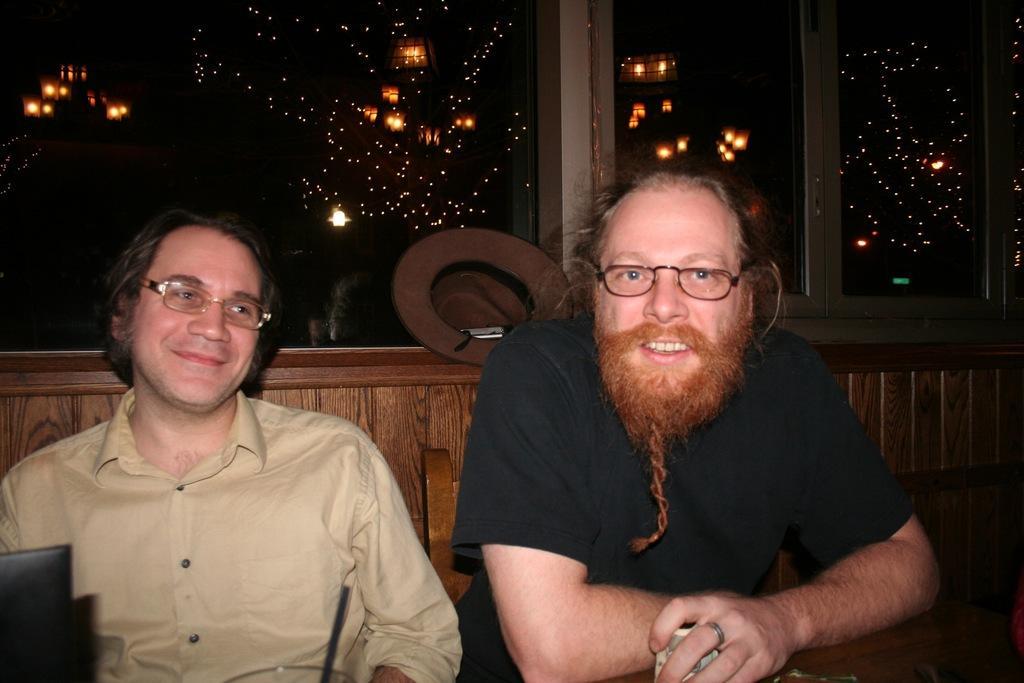Could you give a brief overview of what you see in this image? In this image we can see two persons and behind the Persons there is a wall with a glass. On the glass we can see the reflection of the lights. 